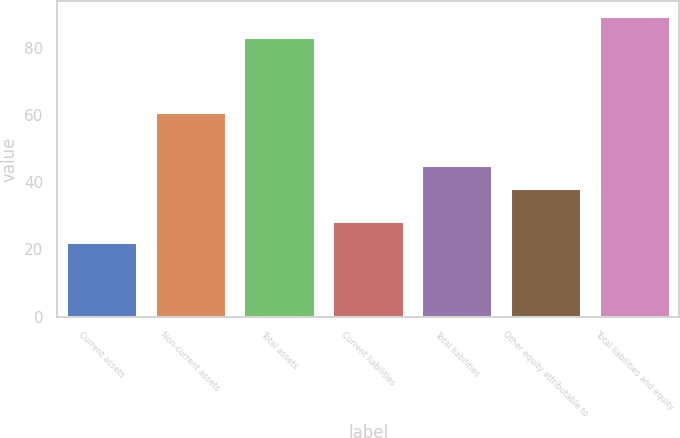Convert chart. <chart><loc_0><loc_0><loc_500><loc_500><bar_chart><fcel>Current assets<fcel>Non-current assets<fcel>Total assets<fcel>Current liabilities<fcel>Total liabilities<fcel>Other equity attributable to<fcel>Total liabilities and equity<nl><fcel>22.3<fcel>61<fcel>83.3<fcel>28.4<fcel>45.1<fcel>38.2<fcel>89.4<nl></chart> 